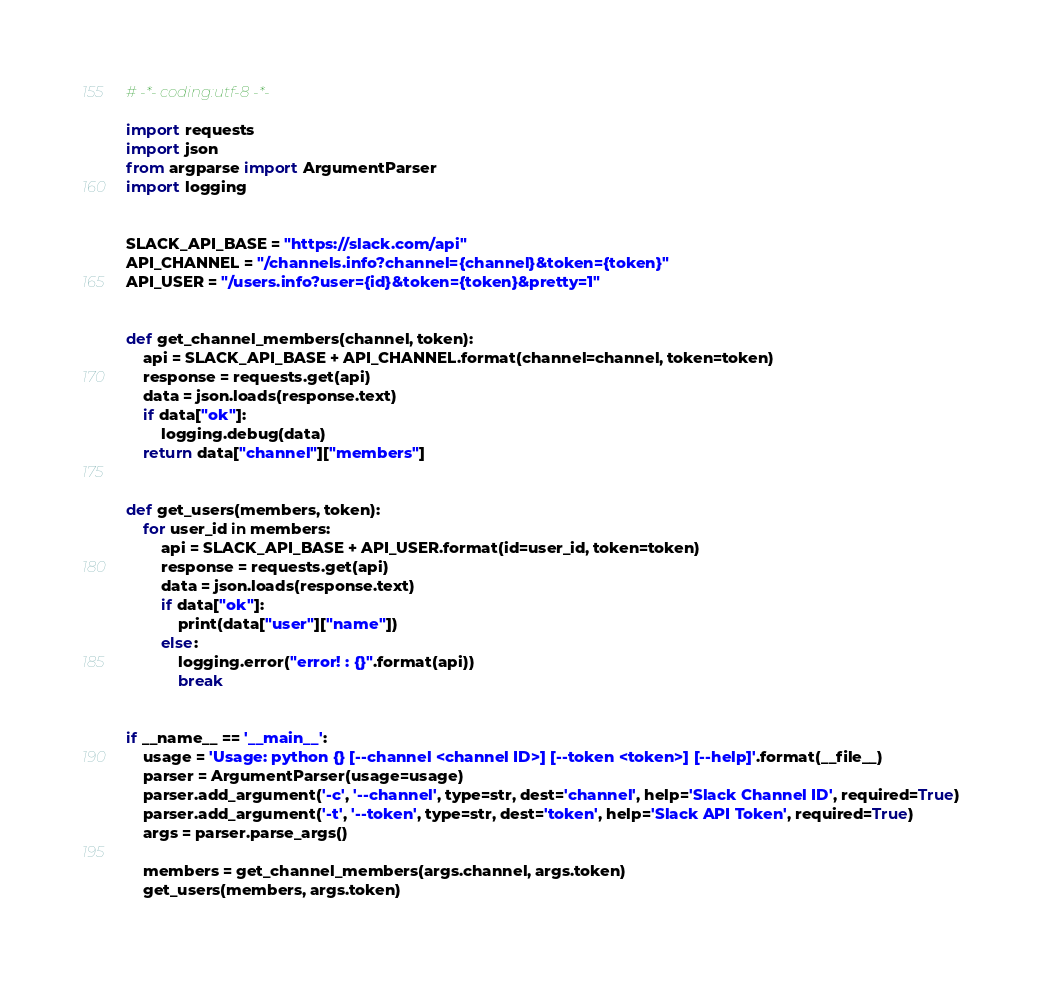Convert code to text. <code><loc_0><loc_0><loc_500><loc_500><_Python_># -*- coding:utf-8 -*-

import requests
import json
from argparse import ArgumentParser
import logging


SLACK_API_BASE = "https://slack.com/api"
API_CHANNEL = "/channels.info?channel={channel}&token={token}"
API_USER = "/users.info?user={id}&token={token}&pretty=1"


def get_channel_members(channel, token):
    api = SLACK_API_BASE + API_CHANNEL.format(channel=channel, token=token)
    response = requests.get(api)
    data = json.loads(response.text)
    if data["ok"]:
        logging.debug(data)
    return data["channel"]["members"]


def get_users(members, token):
    for user_id in members:
        api = SLACK_API_BASE + API_USER.format(id=user_id, token=token)
        response = requests.get(api)
        data = json.loads(response.text)
        if data["ok"]:
            print(data["user"]["name"])
        else:
            logging.error("error! : {}".format(api))
            break


if __name__ == '__main__':
    usage = 'Usage: python {} [--channel <channel ID>] [--token <token>] [--help]'.format(__file__)
    parser = ArgumentParser(usage=usage)
    parser.add_argument('-c', '--channel', type=str, dest='channel', help='Slack Channel ID', required=True)
    parser.add_argument('-t', '--token', type=str, dest='token', help='Slack API Token', required=True)
    args = parser.parse_args()

    members = get_channel_members(args.channel, args.token)
    get_users(members, args.token)
</code> 